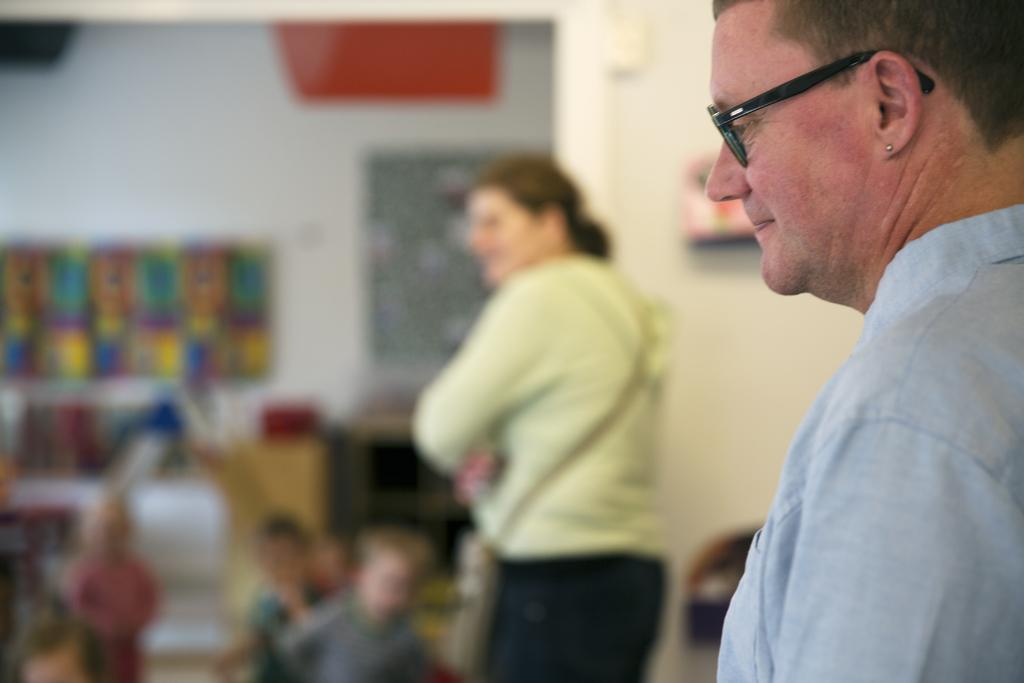Who are the two people on the right side of the image? The facts do not specify the identities of the two people. What are the kids doing in front of the two people? The facts do not specify the actions of the kids. What can be seen on the wall in the image? There are posters attached to the wall. How would you describe the background of the image? The background of the image is blurred. What type of humor is being displayed on the coat of the person on the left side of the image? There is no person on the left side of the image, and no coat is mentioned in the facts. 